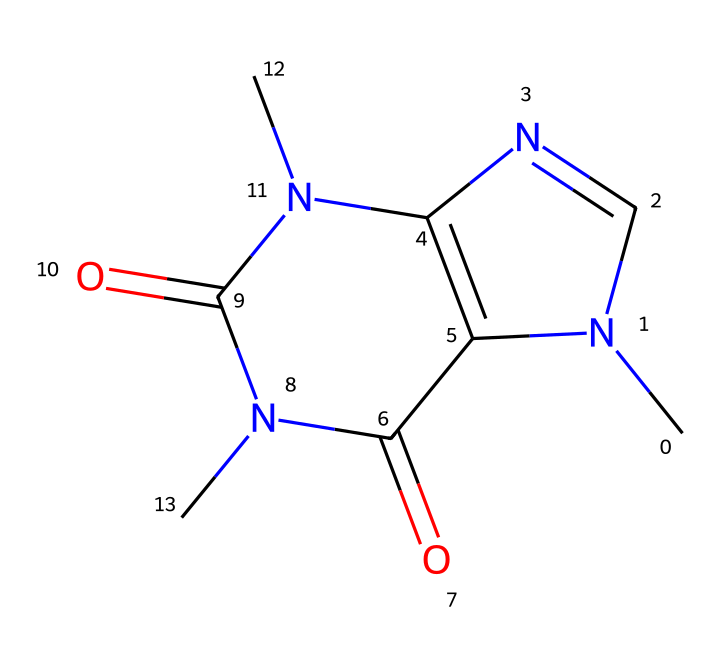What is the IUPAC name of this chemical? The SMILES representation corresponds to the structure of caffeine, which is known as 1,3,7-trimethylxanthine in systematic terms.
Answer: 1,3,7-trimethylxanthine How many nitrogen atoms are present in the structure? By analyzing the SMILES, there are three nitrogen atoms represented in the caffeine structure.
Answer: three What is the molecular formula of caffeine? The structure contains 8 carbon atoms, 10 hydrogen atoms, 4 nitrogen atoms, and 4 oxygen atoms, leading to the molecular formula C8H10N4O2.
Answer: C8H10N4O2 What type of molecule is caffeine classified as? Caffeine is classified as a xanthine alkaloid, which is a subtype of alkaloids due to the presence of nitrogen-containing rings and its physiological effects.
Answer: xanthine alkaloid What functional groups can be identified in caffeine? The molecule has amine and carbonyl functional groups, evident from the nitrogen atoms and the carbonyl (C=O) linkages in its structure.
Answer: amine and carbonyl How might the arrangement of atoms affect caffeine’s solubility? The presence of both polar and nonpolar components due to the amine (basic) and carbonyl (polar) groups makes caffeine moderately soluble in water.
Answer: moderate solubility What property of caffeine contributes to its stimulating effects? The methyl groups attached to the nitrogen in the xanthine ring structure enhance caffeine's ability to cross the blood-brain barrier, contributing to its stimulant effects.
Answer: methyl groups 